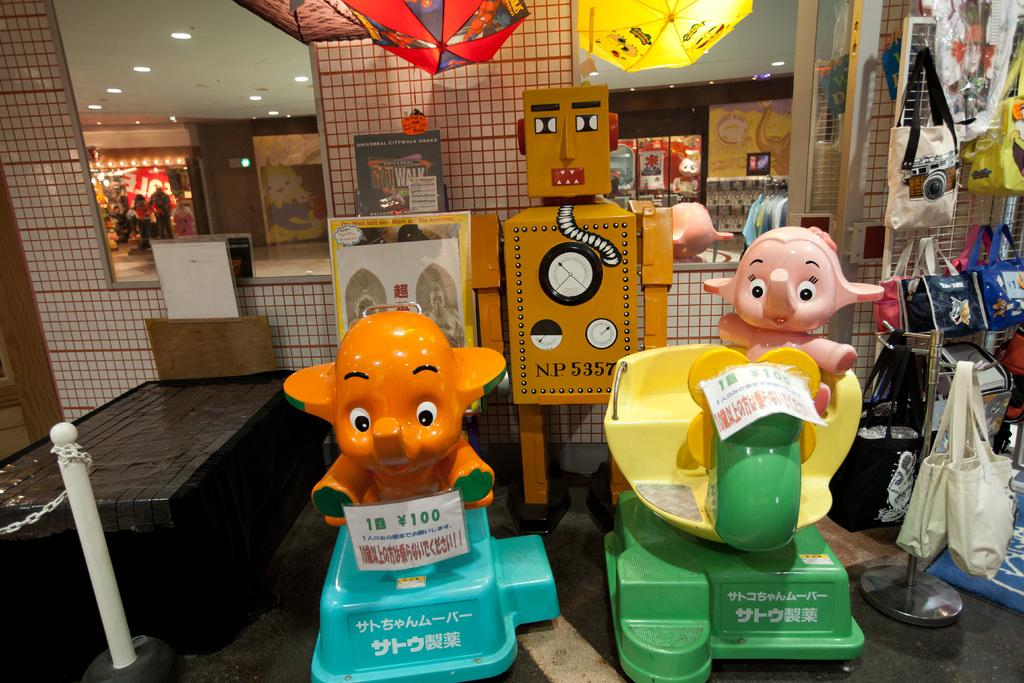What type of toys are present in the image? There are two elephant toys in the image. What other items can be seen on the right side of the image? There are handbags on the right side of the image. What is located at the back side of the image? There are mirrors at the back side of the image. How many sisters are present in the image? There are no sisters present in the image; it features toys, handbags, and mirrors. What type of fear can be seen in the image? There is no fear present in the image; it is a still image of objects. 